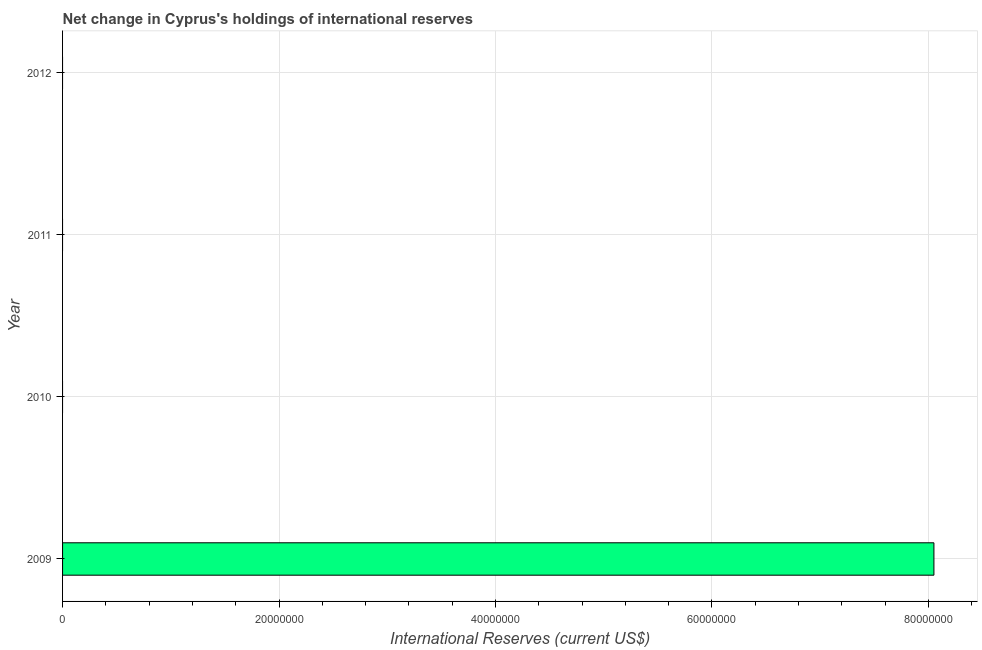Does the graph contain any zero values?
Ensure brevity in your answer.  Yes. What is the title of the graph?
Provide a succinct answer. Net change in Cyprus's holdings of international reserves. What is the label or title of the X-axis?
Your answer should be very brief. International Reserves (current US$). Across all years, what is the maximum reserves and related items?
Make the answer very short. 8.05e+07. In which year was the reserves and related items maximum?
Provide a short and direct response. 2009. What is the sum of the reserves and related items?
Make the answer very short. 8.05e+07. What is the average reserves and related items per year?
Provide a succinct answer. 2.01e+07. What is the median reserves and related items?
Your response must be concise. 0. What is the difference between the highest and the lowest reserves and related items?
Keep it short and to the point. 8.05e+07. How many bars are there?
Make the answer very short. 1. Are all the bars in the graph horizontal?
Your answer should be compact. Yes. How many years are there in the graph?
Your answer should be very brief. 4. Are the values on the major ticks of X-axis written in scientific E-notation?
Your answer should be very brief. No. What is the International Reserves (current US$) in 2009?
Offer a very short reply. 8.05e+07. What is the International Reserves (current US$) in 2010?
Give a very brief answer. 0. What is the International Reserves (current US$) in 2011?
Ensure brevity in your answer.  0. What is the International Reserves (current US$) in 2012?
Offer a terse response. 0. 